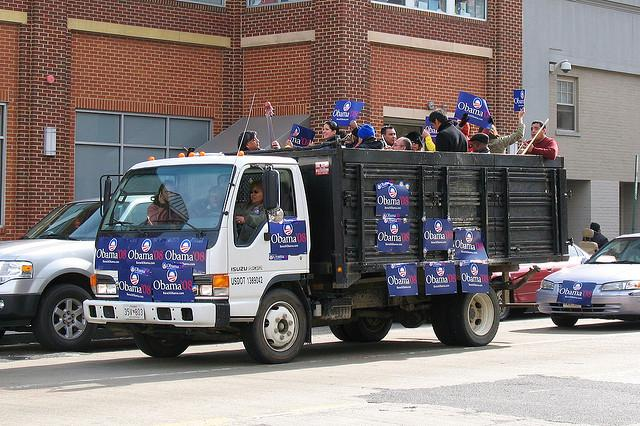Who did they want to be Vice President? biden 